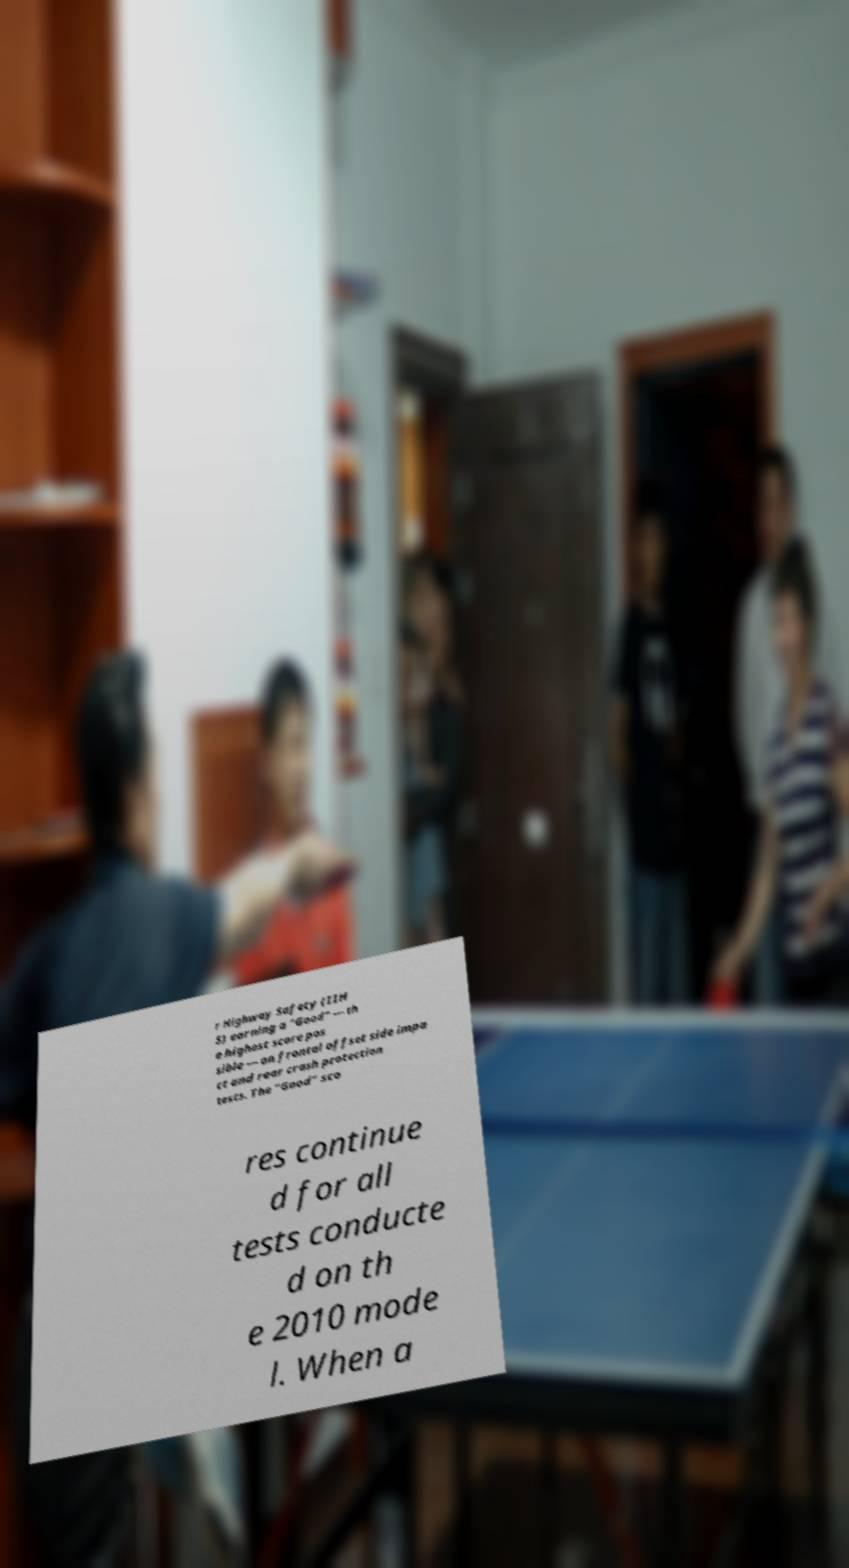Can you read and provide the text displayed in the image?This photo seems to have some interesting text. Can you extract and type it out for me? r Highway Safety (IIH S) earning a "Good" — th e highest score pos sible — on frontal offset side impa ct and rear crash protection tests. The "Good" sco res continue d for all tests conducte d on th e 2010 mode l. When a 